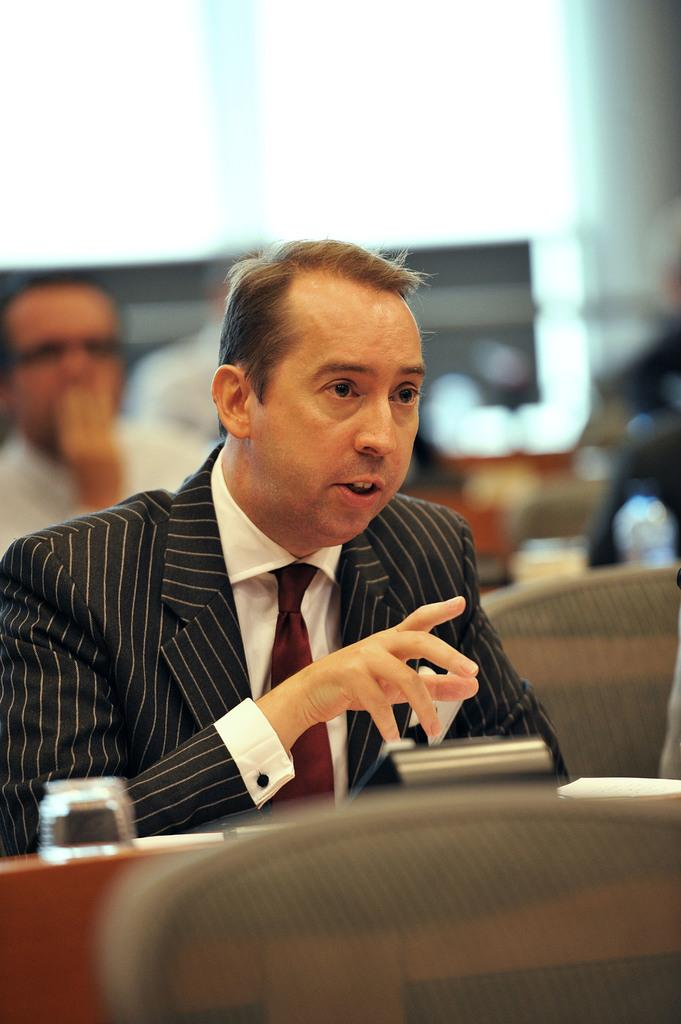How many people are in the image? There are two men in the image. Can you describe the clothing of the man in front? The man in front is wearing a shirt, a tie, and a coat. What can be observed about the background of the image? The background of the image is blurred. What type of substance is falling from the sky in the image? There is no substance falling from the sky in the image. Can you describe the hill in the background of the image? There is no hill present in the image; the background is blurred. 